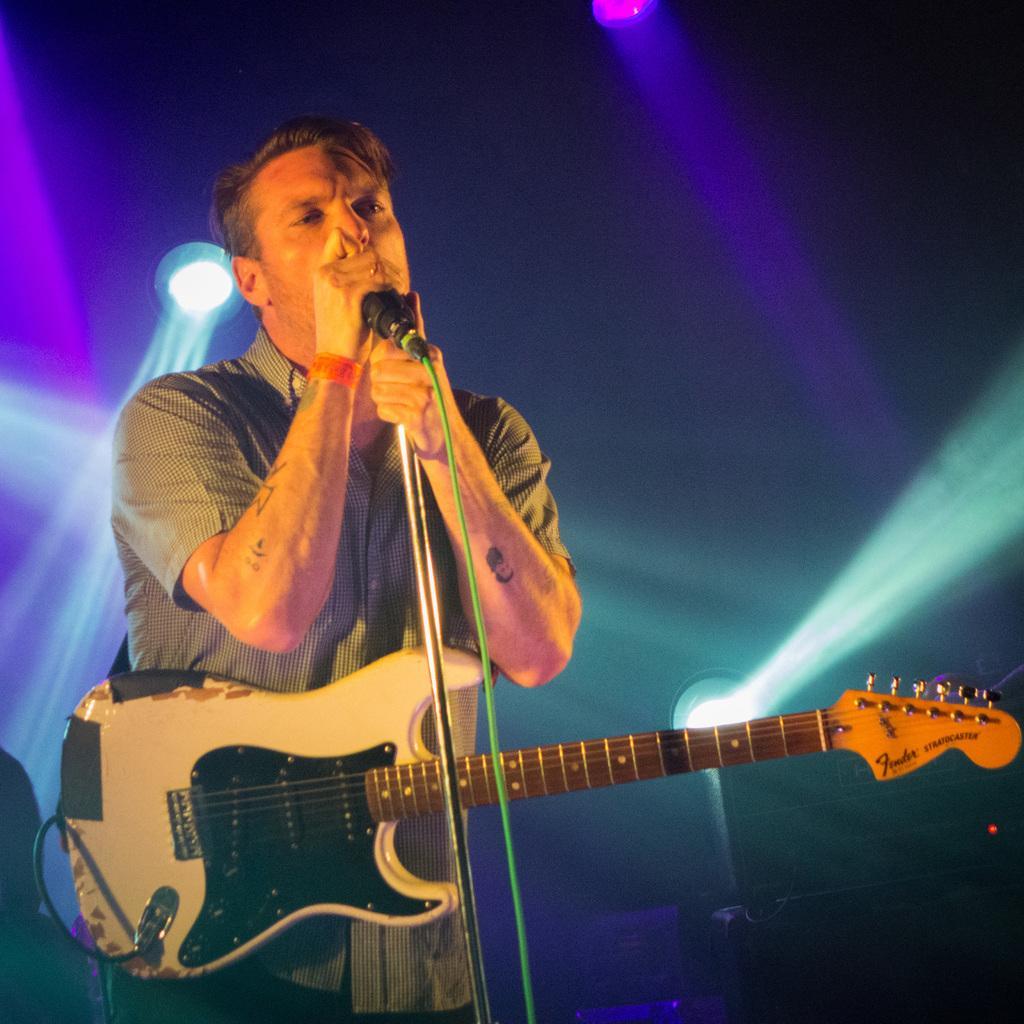Can you describe this image briefly? In the picture we can see a man standing and holding a microphone and singing a song and he is wearing a shirt and holding a guitar for him and in the background we can see some lights. 